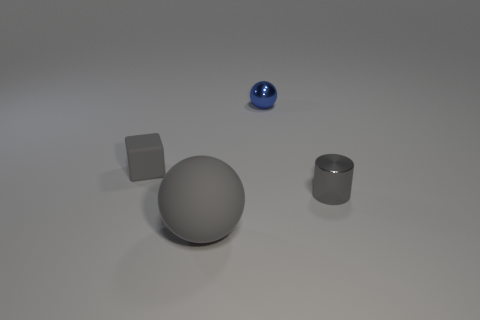Add 1 large gray rubber things. How many objects exist? 5 Subtract all cylinders. How many objects are left? 3 Subtract 0 purple cubes. How many objects are left? 4 Subtract all big things. Subtract all big green metal cylinders. How many objects are left? 3 Add 3 matte blocks. How many matte blocks are left? 4 Add 4 cyan matte cubes. How many cyan matte cubes exist? 4 